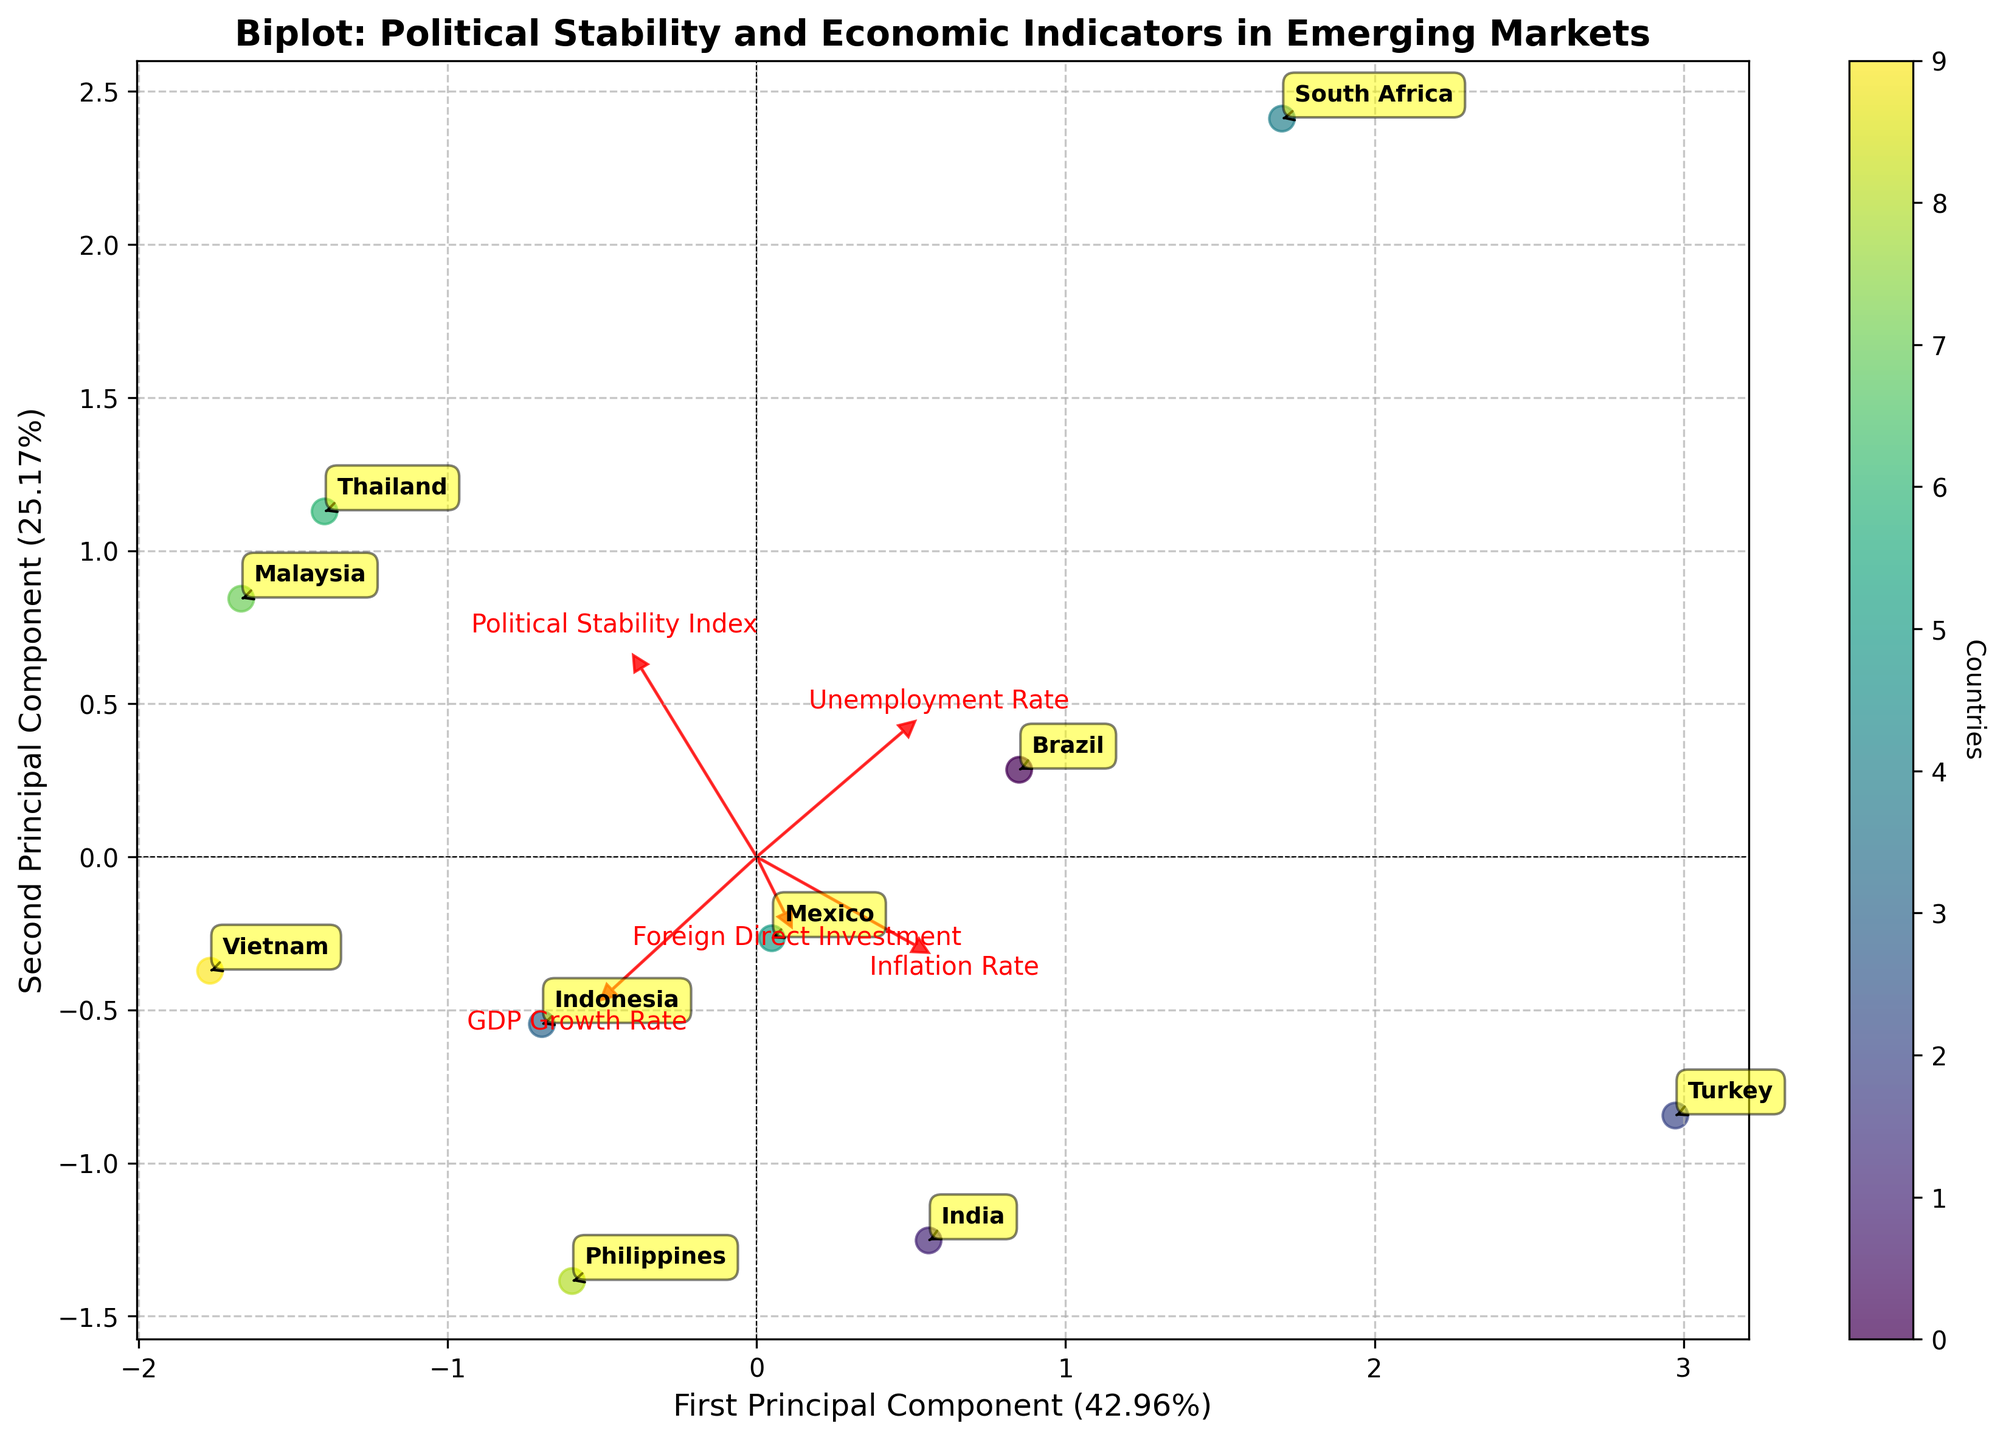What does the biplot title say about the analysis it represents? The title of the biplot provides insight into what is being analyzed. Here, it indicates a relationship between political stability and economic indicators in emerging markets. The title is "Biplot: Political Stability and Economic Indicators in Emerging Markets".
Answer: Biplot: Political Stability and Economic Indicators in Emerging Markets How many countries are represented in the biplot? The biplot shows data points, with each point representing one country. The number can be counted by looking at the labeled country names.
Answer: 10 Which country has the highest Political Stability Index in the biplot? The Political Stability Index values are plotted along the first principal component, with countries further to the right having higher stability. The country furthest to the right on the x-axis is identified as having the highest index.
Answer: Malaysia Which countries are located in the upper right quadrant of the biplot? The upper right quadrant can be identified by both positive principal component values on the x and y axes. By looking at the data points in this quadrant, the countries present there can be found.
Answer: Thailand, Malaysia What is the position of Brazil relative to the origin in the biplot? To determine Brazil's position, one needs to locate its label in the plot and check its coordinates. Its relative position to the origin (0,0) will show its sign on both axes.
Answer: Lower left Which economic indicator is almost aligned with the first principal component? The feature vectors' directions in the biplot help to identify which indicator is almost aligned with the first principal component (x-axis). By matching the arrow that corresponds closely to the horizontal axis, the aligned feature can be found.
Answer: Political Stability Index What does the length and direction of the 'Inflation Rate' vector indicate in the biplot? The length and direction of the vectors represent the extent and direction of the influence of the variables on the principal components. The 'Inflation Rate' vector points toward the lower left quadrant indicating its influence is more probable among countries scoring low on the x-axis and y-axis components. Its relatively shorter length implies a smaller influence comparatively to other vectors.
Answer: Smaller influence, lower left direction Which country has the highest GDP Growth Rate in the biplot? Compare its position with the 'GDP Growth Rate' vector. To identify the highest GDP Growth Rate, check the annotations and locate the country closest to the 'GDP Growth Rate' vector pointing direction. The vector's direction and the position of the Philippines in that direction indicate that Philippines has a high GDP Growth Rate.
Answer: Philippines Considering the relationship between political stability and foreign direct investment, which country appears to be an outlier? Observing the spread of data points and their proximity to the 'Political Stability Index' and 'Foreign Direct Investment' vectors, the one furthest from the typical clustered pattern can be identified as an outlier. South Africa, being significantly distant from the others, is an outlier in the context of these two indicators.
Answer: South Africa 